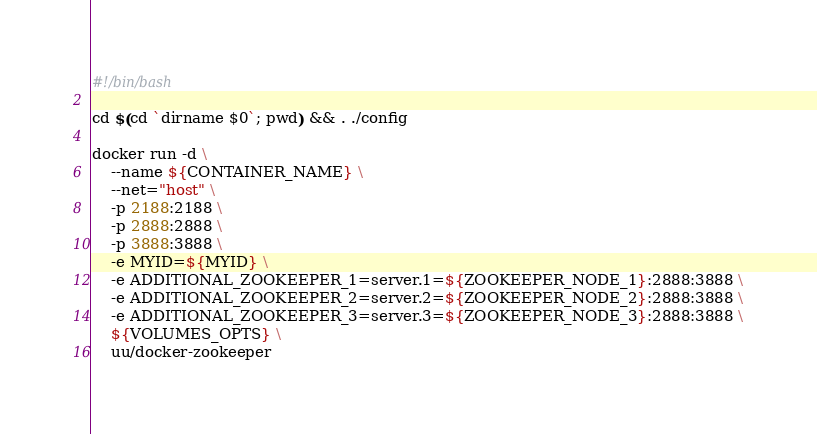Convert code to text. <code><loc_0><loc_0><loc_500><loc_500><_Bash_>#!/bin/bash

cd $(cd `dirname $0`; pwd) && . ./config

docker run -d \
    --name ${CONTAINER_NAME} \
    --net="host" \
    -p 2188:2188 \
    -p 2888:2888 \
    -p 3888:3888 \
    -e MYID=${MYID} \
    -e ADDITIONAL_ZOOKEEPER_1=server.1=${ZOOKEEPER_NODE_1}:2888:3888 \
    -e ADDITIONAL_ZOOKEEPER_2=server.2=${ZOOKEEPER_NODE_2}:2888:3888 \
    -e ADDITIONAL_ZOOKEEPER_3=server.3=${ZOOKEEPER_NODE_3}:2888:3888 \
    ${VOLUMES_OPTS} \
    uu/docker-zookeeper
</code> 